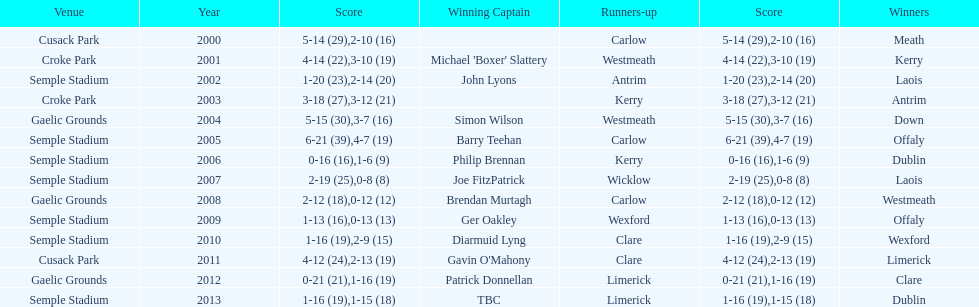Which team was the previous winner before dublin in 2013? Clare. 